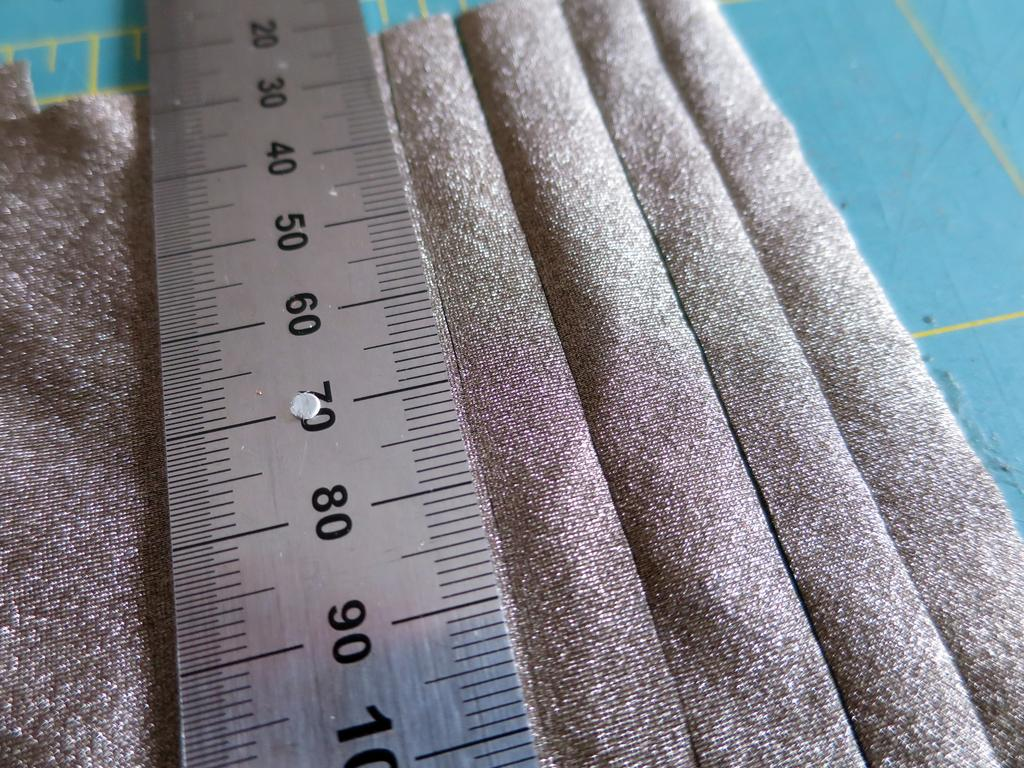Provide a one-sentence caption for the provided image. A metal ruler with the numbers 20 through 100 displayed. 